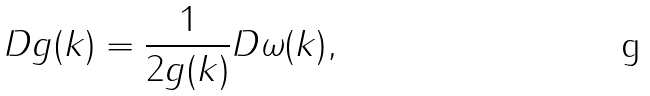Convert formula to latex. <formula><loc_0><loc_0><loc_500><loc_500>D g ( k ) = \frac { 1 } { 2 g ( k ) } D \omega ( k ) ,</formula> 